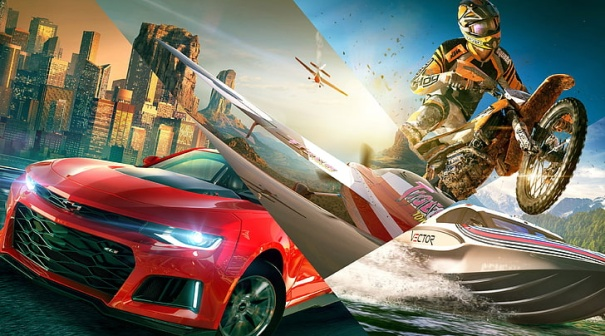Describe the following image. In the image, a vibrant red sports car prominently occupies the foreground, showcasing a sleek, aerodynamic design and a shiny, flawless finish. The car's bold presence is further emphasized by its bright red color, which instantly grabs attention. Behind the car, a thrill-seeking motorcyclist is captured in mid-air performing an impressive and adventurous jump, contributing a dynamic and exhilarating element to the scene. The motorcyclist suggests a feeling of extreme sport, adventure, and speed.

Also visible in the backdrop is a speedboat, cutting through the water with power and agility, its wake dramatically trailing behind. The speedboat adds a sense of aquatic adventure and high-speed excitement, creating a multi-dimensional dynamic atmosphere.

The entire scene is framed against the backdrop of a modern city skyline, featuring towering skyscrapers that add an urban flavor to the image. Even further back, majestic mountains rise towards the sky, providing a contrasting natural element to the urban setting. The juxtaposition of city and nature elements enhances the overall richness of the scene.

Interestingly, a small aircraft is also visible in the distance, soaring high above, adding an aerial dimension to the already diverse scene. This element suggests the breadth of motion and speed across different modes of transport present in the image.

The image focuses exclusively on these visual elements without any text distractions. The overall composition and positioning of each object create a harmonious balance, conveying a cohesive sense of motion and speed. The meticulously maintained spacing ensures that each visual element makes its presence felt without overshadowing the others.

Overall, the scene depicts a futuristic world, amplified by the stylized portrayal of the vehicles and the sprawling cityscape. The vivid colors, particularly the striking red of the sports car, enhance the futuristic and vibrant feeling, creating a scenario that seems straight out of a high-octane, adventure-packed future. 